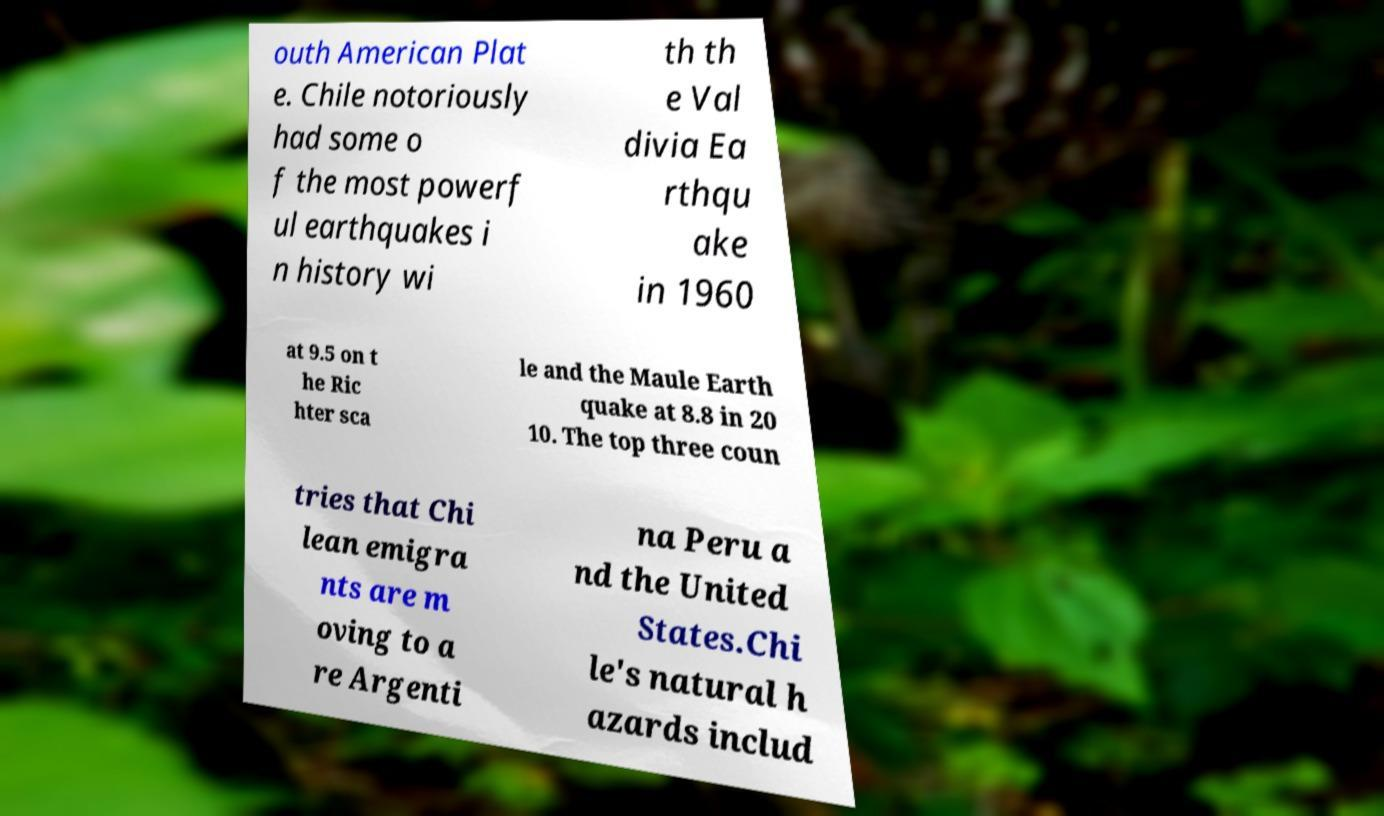There's text embedded in this image that I need extracted. Can you transcribe it verbatim? outh American Plat e. Chile notoriously had some o f the most powerf ul earthquakes i n history wi th th e Val divia Ea rthqu ake in 1960 at 9.5 on t he Ric hter sca le and the Maule Earth quake at 8.8 in 20 10. The top three coun tries that Chi lean emigra nts are m oving to a re Argenti na Peru a nd the United States.Chi le's natural h azards includ 